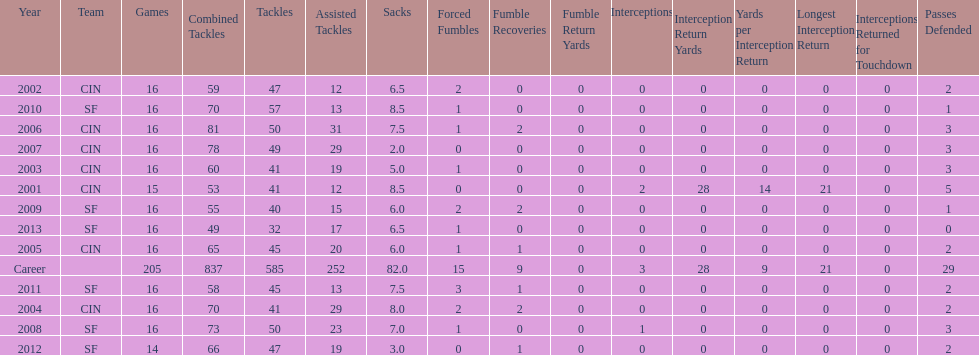What is the total number of sacks smith has made? 82.0. 